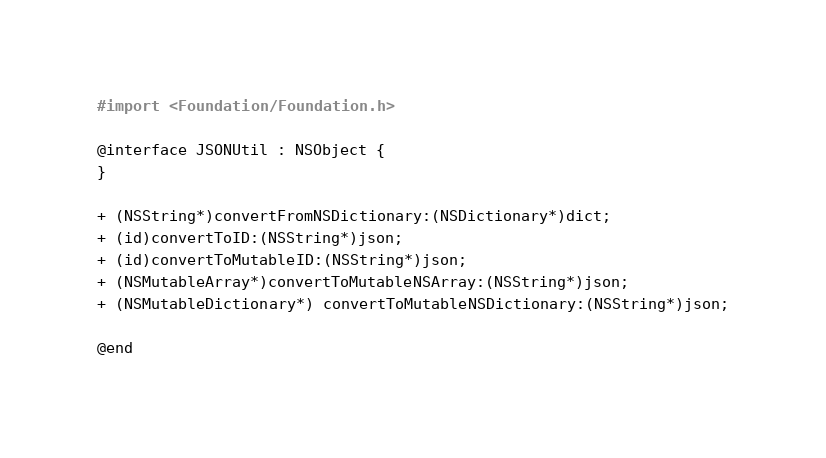<code> <loc_0><loc_0><loc_500><loc_500><_C_>#import <Foundation/Foundation.h>

@interface JSONUtil : NSObject {
}

+ (NSString*)convertFromNSDictionary:(NSDictionary*)dict;
+ (id)convertToID:(NSString*)json;
+ (id)convertToMutableID:(NSString*)json;
+ (NSMutableArray*)convertToMutableNSArray:(NSString*)json;
+ (NSMutableDictionary*) convertToMutableNSDictionary:(NSString*)json;

@end
</code> 